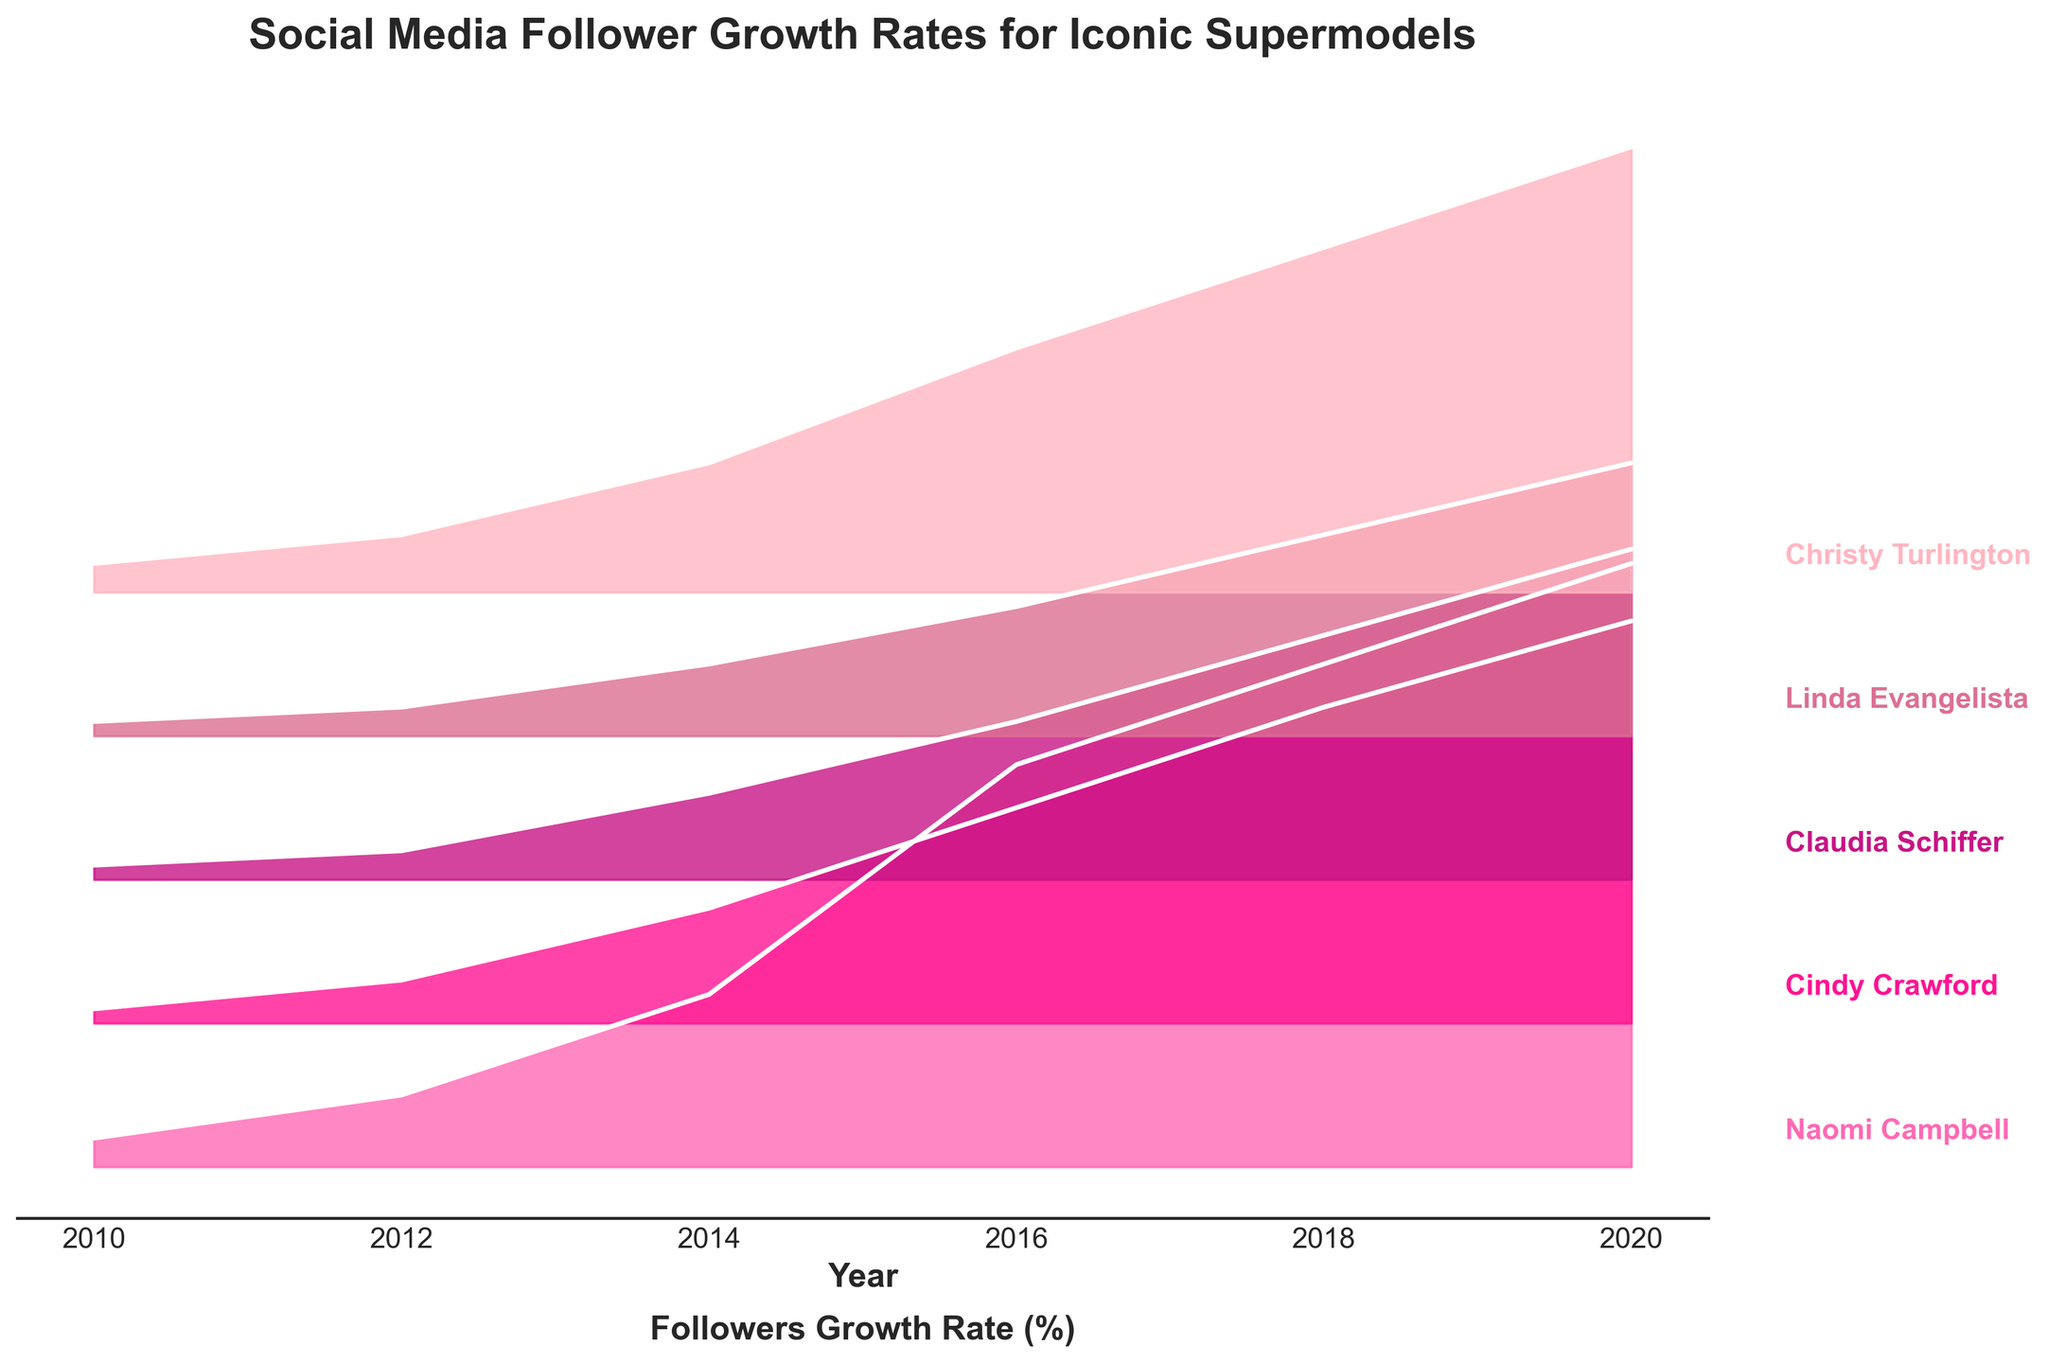What's the title of the plot? The title is located at the top of the plot and describes what the plot is about. It usually presents a summary of the figure's contents.
Answer: Social Media Follower Growth Rates for Iconic Supermodels What is the y-axis representing in the plot? The y-axis in this Ridgeline plot does not have labeled ticks because it is used to display different models' names, which are written adjacent to their respective ridgelines.
Answer: Different supermodels How many supermodels' data are shown in the plot? By counting the different labels along the y-axis, we can determine the number of supermodels represented in the plot.
Answer: 5 supermodels What's the trend of Naomi Campbell's followers' growth rate from 2010 to 2020? The ridgeline for Naomi Campbell shows an increasing fill and line plot over the years, indicating a growing trend in her followers' growth rate.
Answer: Increasing Which model had the highest followers' growth rate in 2020? By looking at the data points for the year 2020 across all supermodels, the highest position on the y-axis can be identified. It is the model whose ridgeline shows the highest peak for 2020.
Answer: Naomi Campbell Is Cindy Crawford's followers' growth rate in 2018 higher than in 2014? By comparing the ridgeline for Cindy Crawford at the years 2014 and 2018, the position of the fill and the plotted line heights can be measured.
Answer: Yes Which supermodel had the slowest growth in followers in 2012? Compare the ridgelines for all models at the year 2012. Find the model with the lowest peak.
Answer: Claudia Schiffer By how much did Christy Turlington's followers' growth rate increase from 2016 to 2020? To determine this, find the difference between the heights of Christy Turlington's ridgeline at 2020 and 2016. This involves subtracting the 2016 growth rate from the 2020 rate.
Answer: 1.4 Which model had a significant jump in followers' growth rate between 2014 and 2016? Look for the ridgeline that shows a steep increase between these two years, indicating a significant jump in followers' growth rate.
Answer: Naomi Campbell Comparing Linda Evangelista and Claudia Schiffer, who had a consistently higher growth rate of followers from 2010 to 2020? By comparing the ridgelines of Linda Evangelista and Claudia Schiffer over the years 2010 to 2020, observe the height of the ridgelines on the y-axis to see which one consistently stays higher.
Answer: Claudia Schiffer 